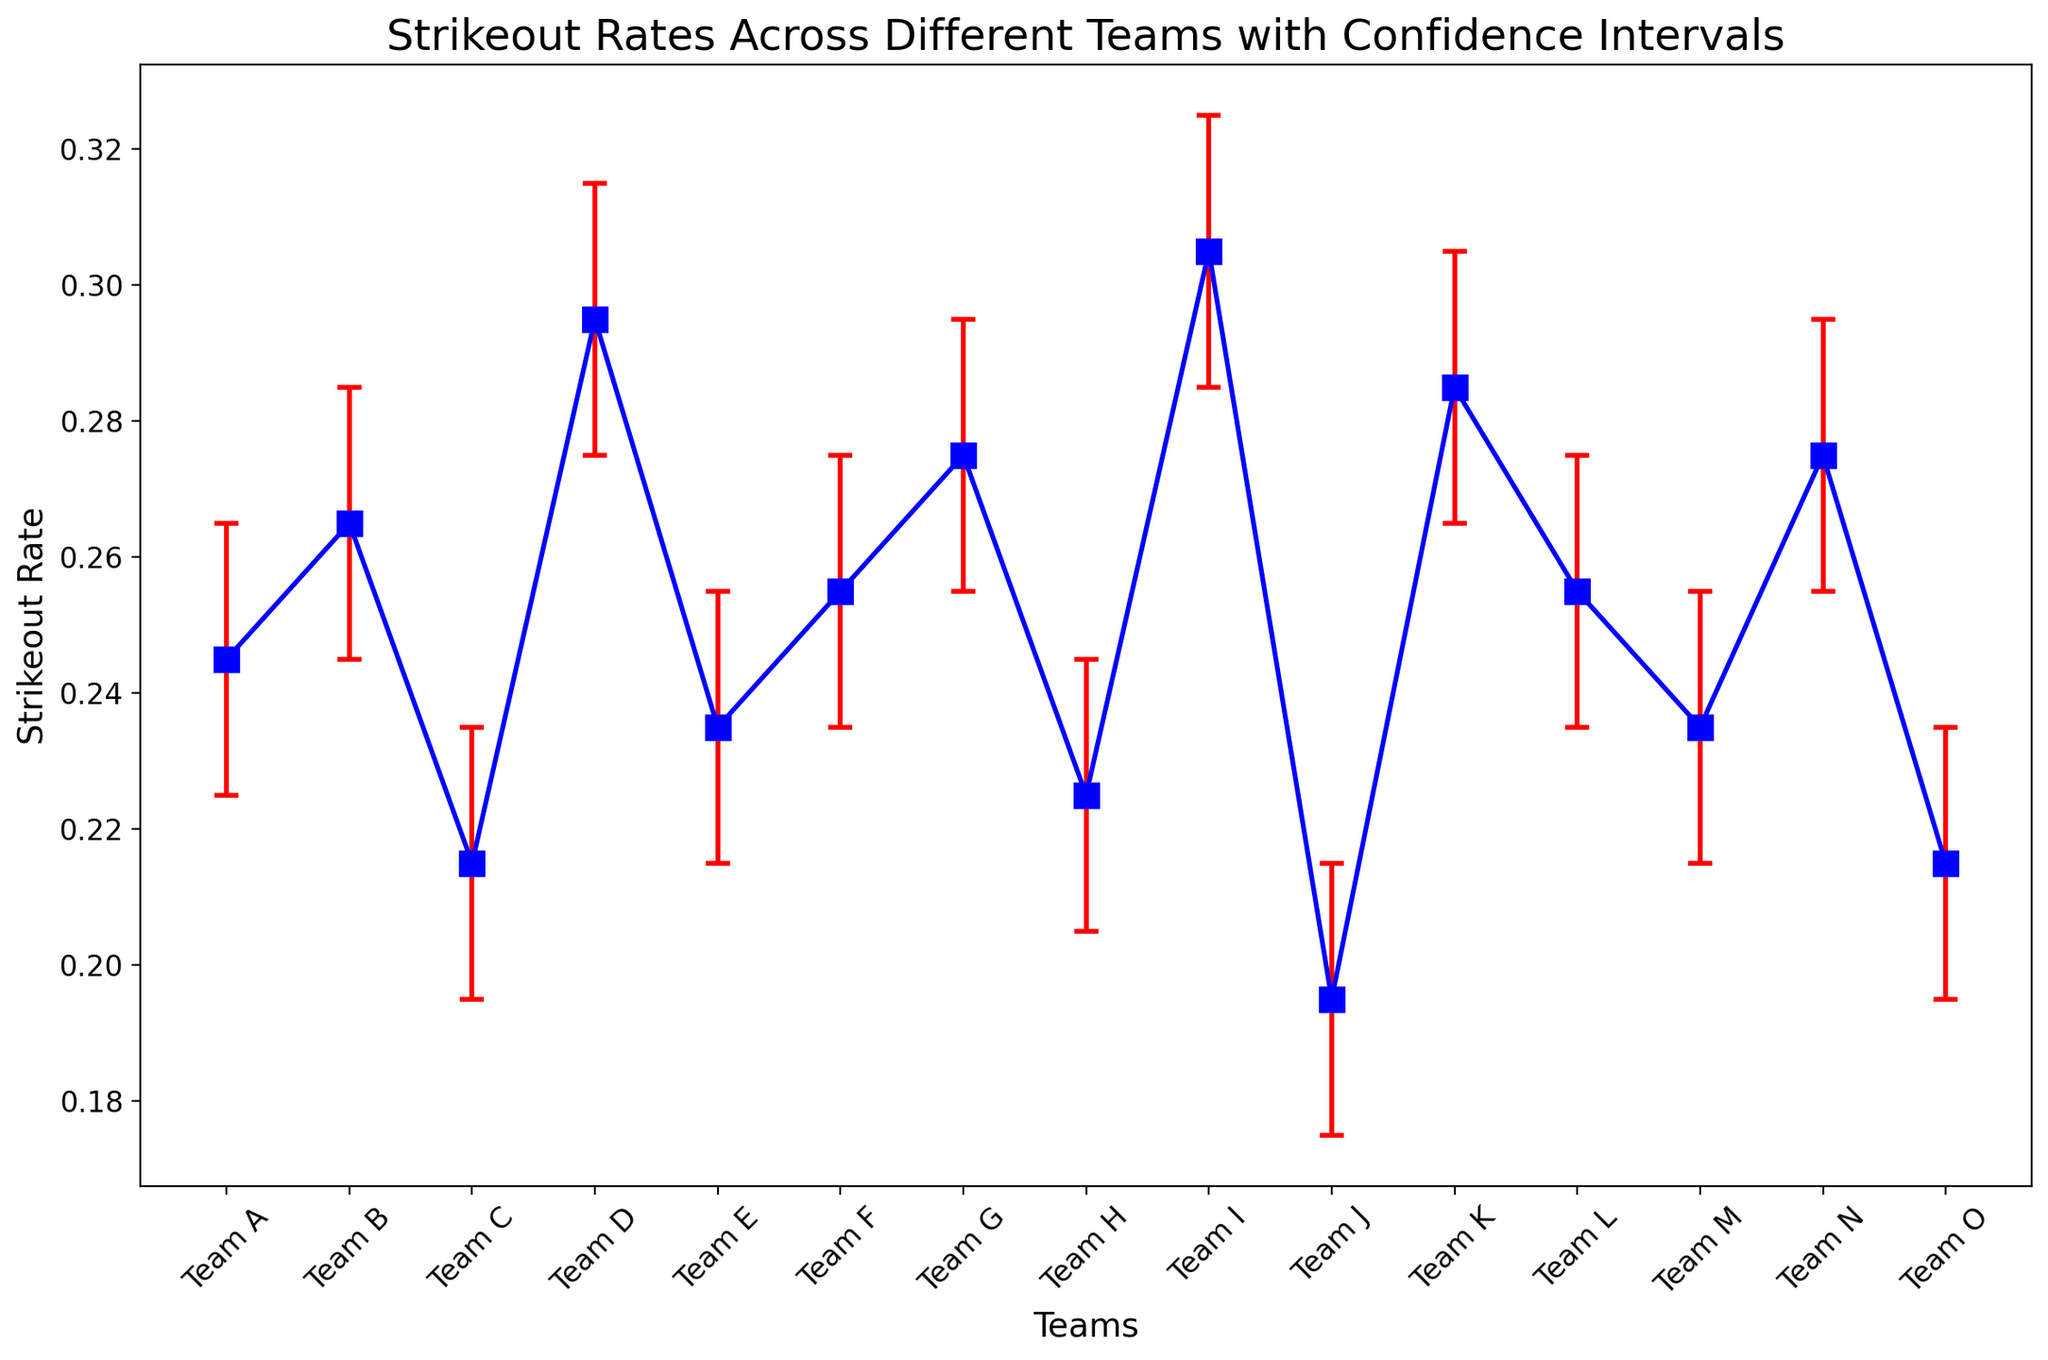Which team has the highest strikeout rate? Team I has the highest strikeout rate visible on the plot. It has a strikeout rate around 0.305.
Answer: Team I Which team has the lowest strikeout rate? Team J has the lowest strikeout rate shown in the figure, with a rate of approximately 0.195.
Answer: Team J What is the average strikeout rate of Team A, B, and C? Add the strikeout rates of Team A (0.245), Team B (0.265), and Team C (0.215), and then divide by 3. (0.245 + 0.265 + 0.215) / 3 = 0.241666.
Answer: 0.242 Which team has a higher strikeout rate, Team E or Team L? Compare the strikeout rates: Team E has 0.235 and Team L has 0.255. Since 0.255 > 0.235, Team L has a higher strikeout rate.
Answer: Team L Which team has the widest confidence interval? Team I has the widest confidence interval among the teams because the length between the lower_ci (0.285) and upper_ci (0.325) is the largest: 0.325 - 0.285 = 0.04.
Answer: Team I Between Team D and Team G, which team has the smaller confidence interval length? Compare the confidence interval length: Team D has 0.295 - 0.275 = 0.02, and Team G has 0.275 - 0.255 = 0.02. They both have the same interval length.
Answer: Both have the same What is the total sum of the upper confidence intervals for Team A and Team N? Add the upper confidence intervals for Team A (0.265) and Team N (0.295). (0.265 + 0.295) = 0.56.
Answer: 0.56 Which team has a strikeout rate closest to the overall average of all teams' strikeout rates? Calculate the strikeout rates of all the teams and find the average, then find the team closest to this average. Average = (0.245 + 0.265 + 0.215 + 0.295 + 0.235 + 0.255 + 0.275 + 0.225 + 0.305 + 0.195 + 0.285 + 0.255 + 0.235 + 0.275 + 0.215)/15 = 0.255. Team F and Team L are closest with a strikeout rate of 0.255.
Answer: Team F and Team L Does Team M or Team O have a lower bound for the confidence interval closer to their respective strikeout rates? Calculate the difference between the strikeout rate and the lower confidence interval for both teams: Team M has 0.235 - 0.215 = 0.02 and Team O has 0.215 - 0.195 = 0.02. Both teams have the same difference.
Answer: Both Which team's strikeout rate falls entirely within the confidence interval of Team B? The confidence interval of Team B is 0.245 to 0.285. Check which team's strikeout rate is within this range: Teams A, F, L, and N have their strikeout rates within this range (0.245, 0.255, 0.255, 0.275).
Answer: Teams A, F, L, and N 